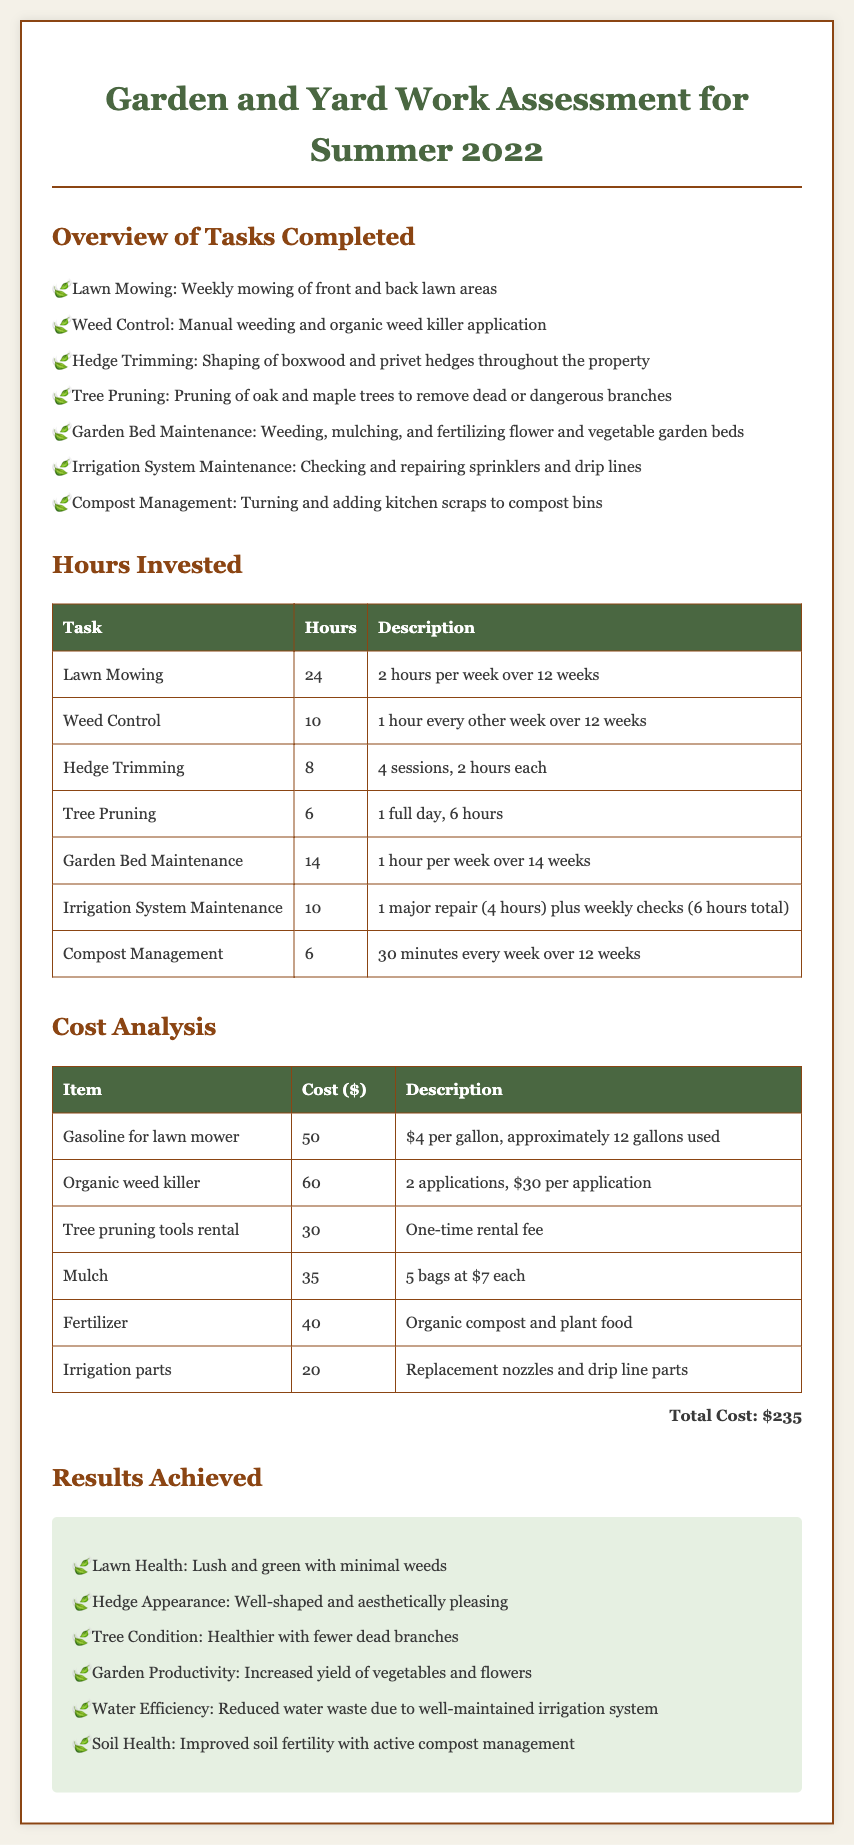What tasks were completed? The tasks completed are listed under the "Overview of Tasks Completed" section, which includes various gardening and yard work activities.
Answer: Lawn Mowing, Weed Control, Hedge Trimming, Tree Pruning, Garden Bed Maintenance, Irrigation System Maintenance, Compost Management How many hours were invested in lawn mowing? The hours invested in lawn mowing are detailed in the "Hours Invested" table, specifically for the lawn mowing task.
Answer: 24 What is the total cost reported? The total cost is mentioned at the bottom of the "Cost Analysis" section as the sum of all individual costs.
Answer: $235 How many weeks was garden bed maintenance performed? The duration of garden bed maintenance is specified as 14 weeks in the "Hours Invested" table.
Answer: 14 weeks What was the cost of the organic weed killer? The cost of the organic weed killer is provided in the "Cost Analysis" table under that item.
Answer: $60 How many sessions were devoted to hedge trimming? The number of sessions for hedge trimming is indicated in the hours invested section, under the task description.
Answer: 4 sessions What improvement was noted in lawn health? The results achieved in lawn health are summarized in the "Results Achieved" section of the document.
Answer: Lush and green with minimal weeds What maintenance was done on the irrigation system? The specific maintenance tasks for the irrigation system can be found in the "Overview of Tasks Completed" section.
Answer: Checking and repairing sprinklers and drip lines Which task required a one-time rental fee for tools? The task that mentions a one-time rental fee for tools indicates that this relates to tree pruning in the "Cost Analysis" table.
Answer: Tree pruning tools rental 